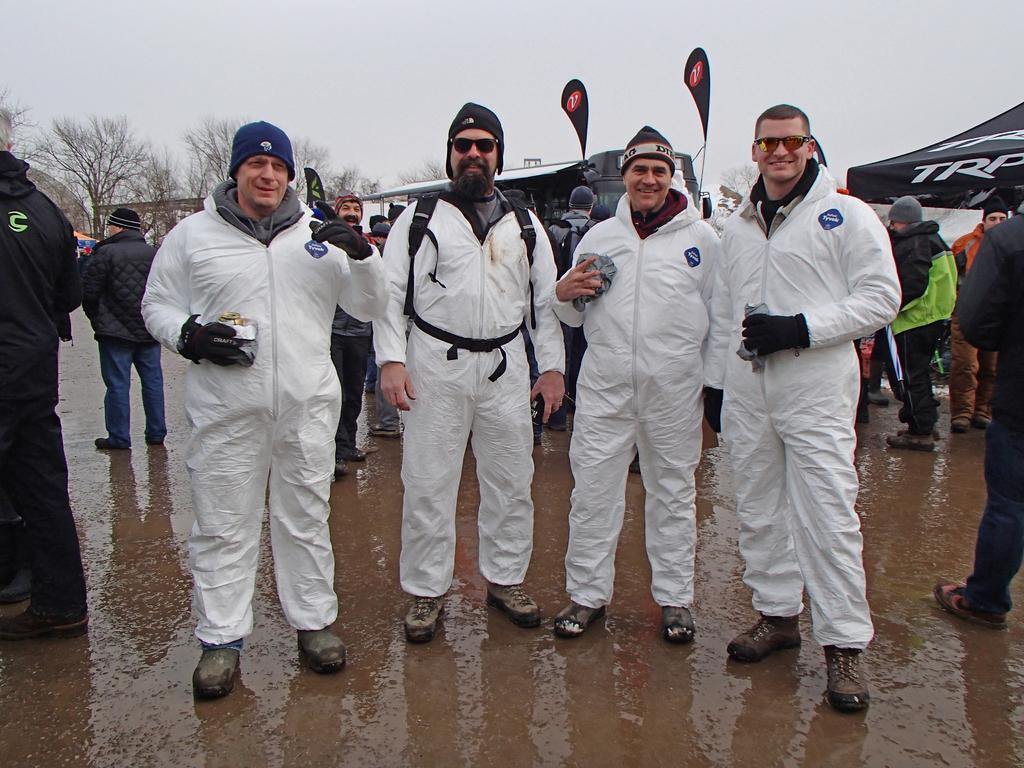In one or two sentences, can you explain what this image depicts? In the image in the center, we can see four people are standing and they are smiling. And we can see they are holding some objects. In the background, we can see the sky, clouds, trees, tents and few people are standing. 